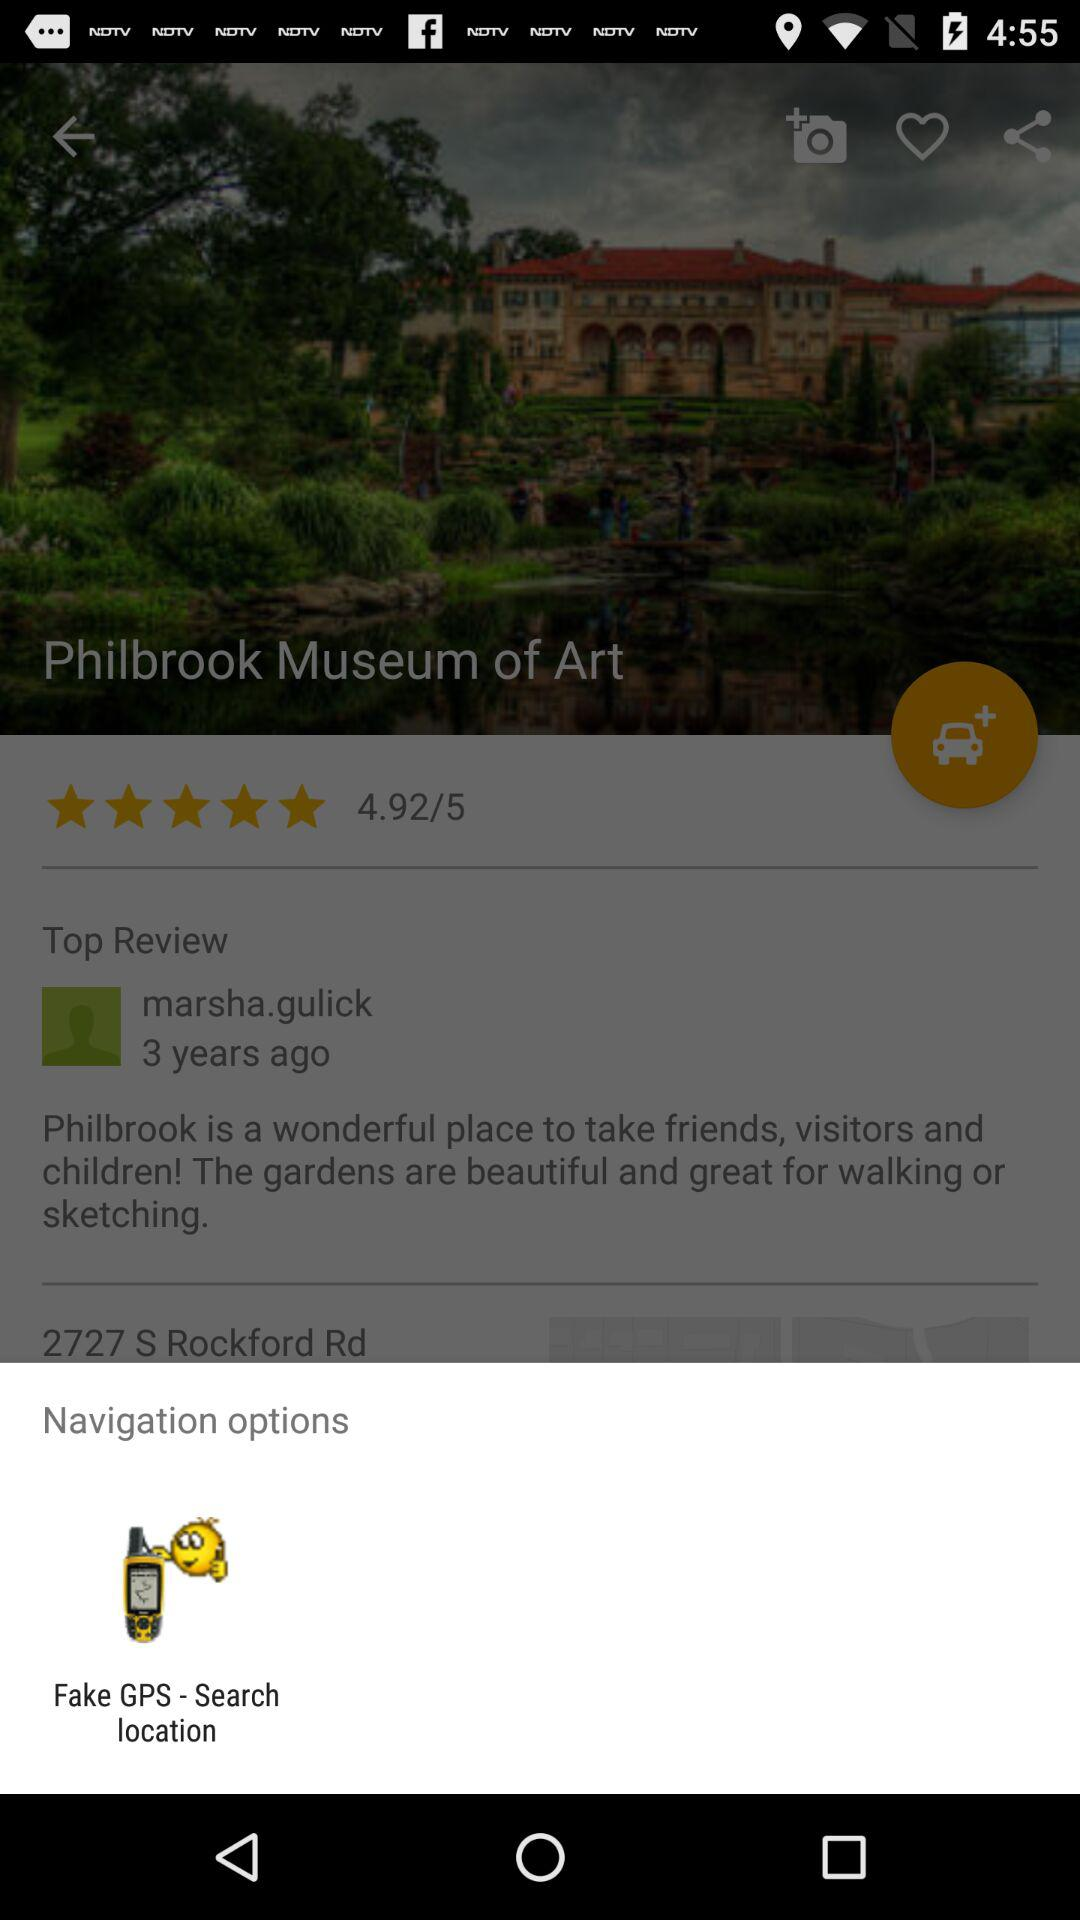What are the navigation options? The navigation option is "Fake GPS - Search location". 